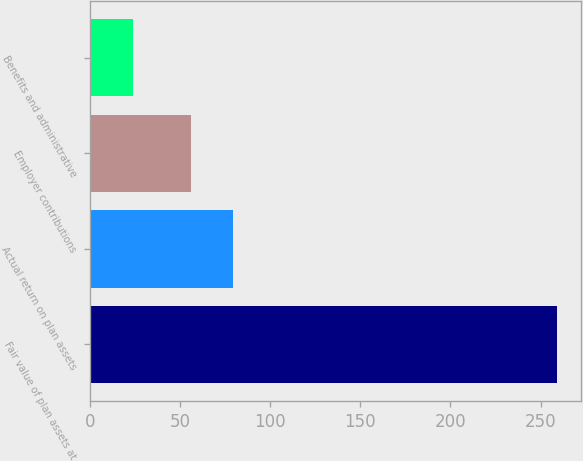Convert chart. <chart><loc_0><loc_0><loc_500><loc_500><bar_chart><fcel>Fair value of plan assets at<fcel>Actual return on plan assets<fcel>Employer contributions<fcel>Benefits and administrative<nl><fcel>259.3<fcel>79.42<fcel>55.9<fcel>24.1<nl></chart> 